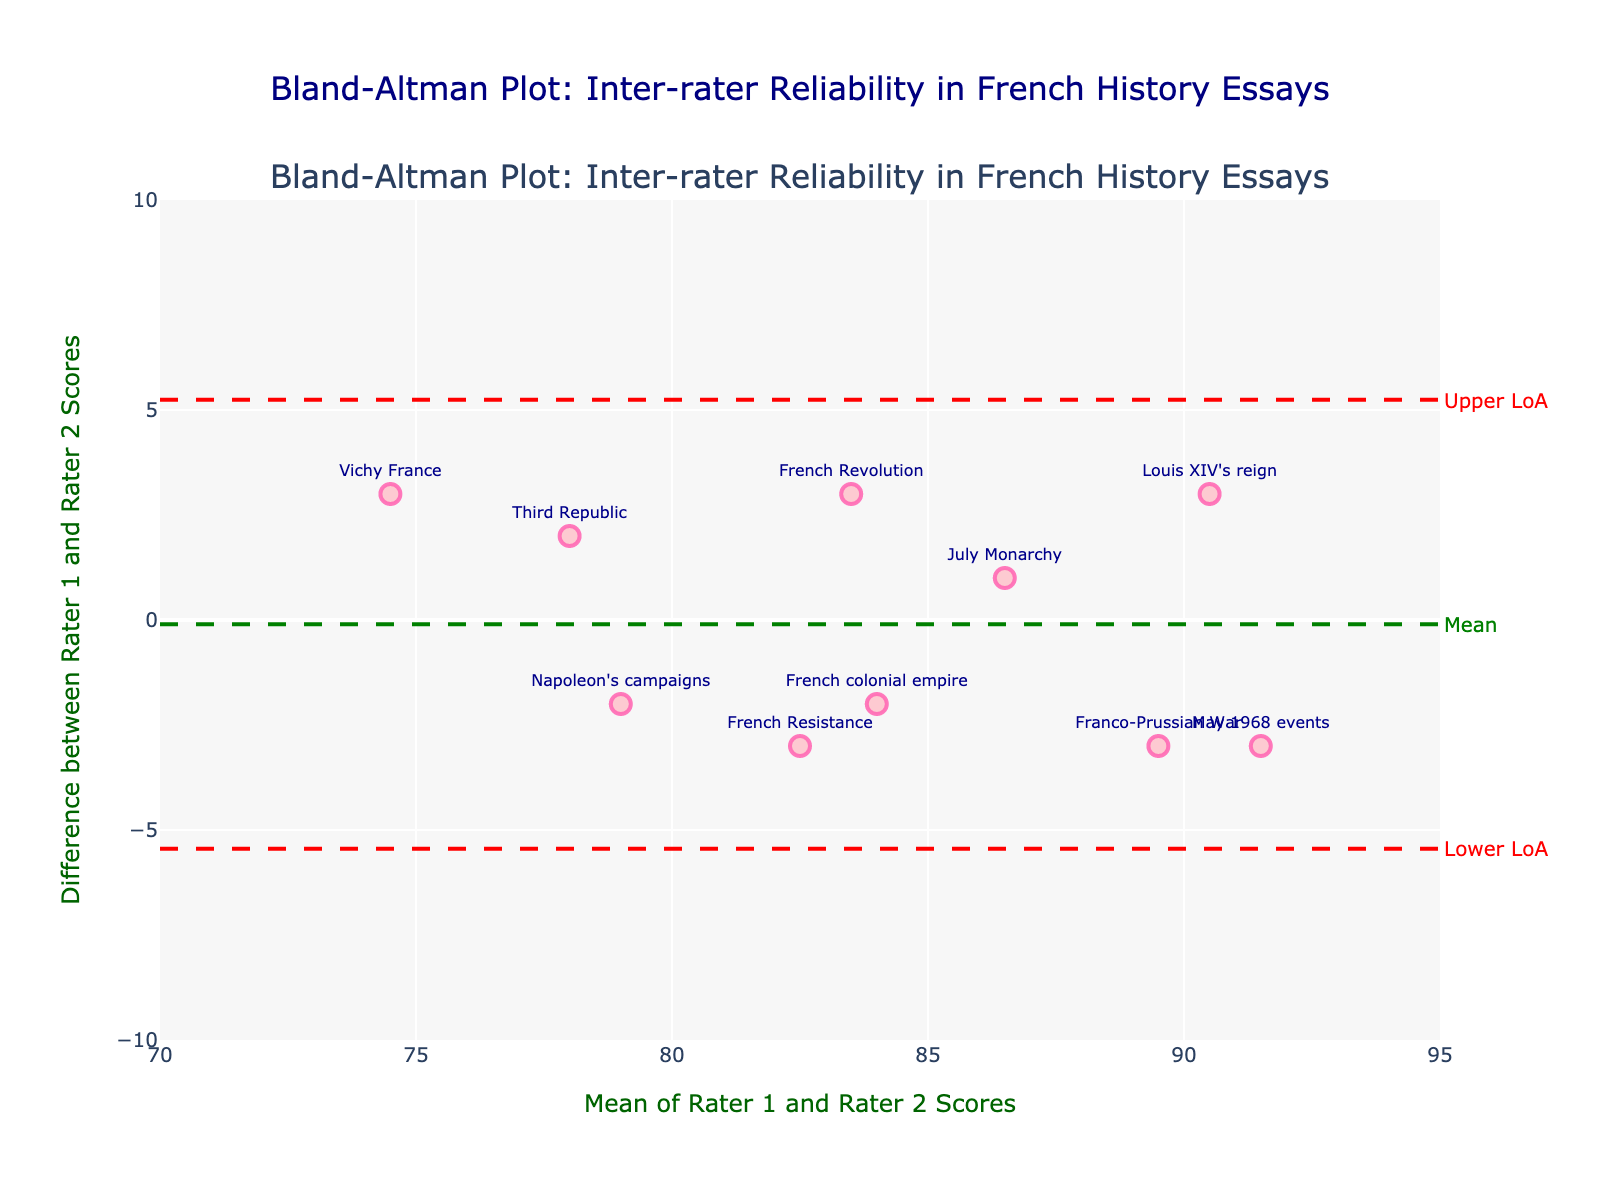What is the title of the plot? The title of the plot is located at the top center of the figure and states its purpose. It provides a summary of what the plot is intended to illustrate.
Answer: Bland-Altman Plot: Inter-rater Reliability in French History Essays What are the axis titles in the plot? The axis titles are labels that describe what each axis represents. They are usually found along the x-axis and y-axis.
Answer: Mean of Rater 1 and Rater 2 Scores (x-axis), Difference between Rater 1 and Rater 2 Scores (y-axis) How many data points are plotted in the figure? To find the number of data points, count the individual markers scattered around the plot.
Answer: 10 Which essay topic has the highest mean score between the two raters? To determine this, look at the x-axis values and identify the highest one. The x-axis represents the mean of Rater 1 and Rater 2 scores. Check the corresponding text label for the highest data point.
Answer: May 1968 events What is the mean difference between Rater 1 and Rater 2 scores? The mean difference is often represented by a horizontal line labeled "Mean" on the plot. This summary statistic shows the average difference between the two sets of scores.
Answer: 0.2 What are the lower and upper limits of agreement (LoA) for the plot? The limits of agreement are represented by horizontal dashed lines and are usually labeled "Lower LoA" and "Upper LoA." These lines provide a range within which most differences between scores are expected to fall.
Answer: Lower LoA: -4.708, Upper LoA: 5.108 Which essay topic has the largest discrepancy between the two raters' scores? To determine this, look at the data point with the largest y-axis value, since the y-axis shows the difference between Rater 1 and Rater 2 scores. The corresponding text label will indicate the essay topic.
Answer: Louis XIV's reign Are there any data points falling outside the limits of agreement? Check whether there are any points above the upper dashed line or below the lower dashed line, indicating they fall outside the expected range.
Answer: No What can be inferred if the data points are clustered around the mean difference line? If data points are clustered around the mean difference line, it indicates good agreement between the raters, as the differences are small and centered around the average difference.
Answer: Good agreement between raters 